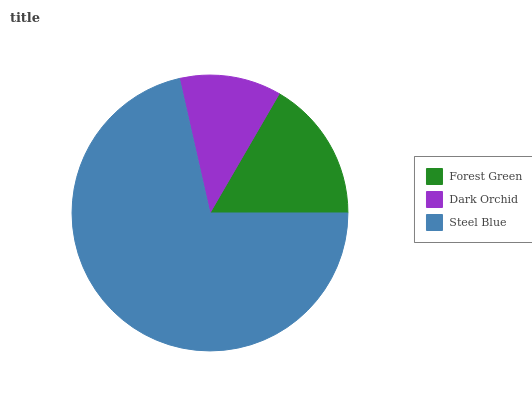Is Dark Orchid the minimum?
Answer yes or no. Yes. Is Steel Blue the maximum?
Answer yes or no. Yes. Is Steel Blue the minimum?
Answer yes or no. No. Is Dark Orchid the maximum?
Answer yes or no. No. Is Steel Blue greater than Dark Orchid?
Answer yes or no. Yes. Is Dark Orchid less than Steel Blue?
Answer yes or no. Yes. Is Dark Orchid greater than Steel Blue?
Answer yes or no. No. Is Steel Blue less than Dark Orchid?
Answer yes or no. No. Is Forest Green the high median?
Answer yes or no. Yes. Is Forest Green the low median?
Answer yes or no. Yes. Is Dark Orchid the high median?
Answer yes or no. No. Is Dark Orchid the low median?
Answer yes or no. No. 